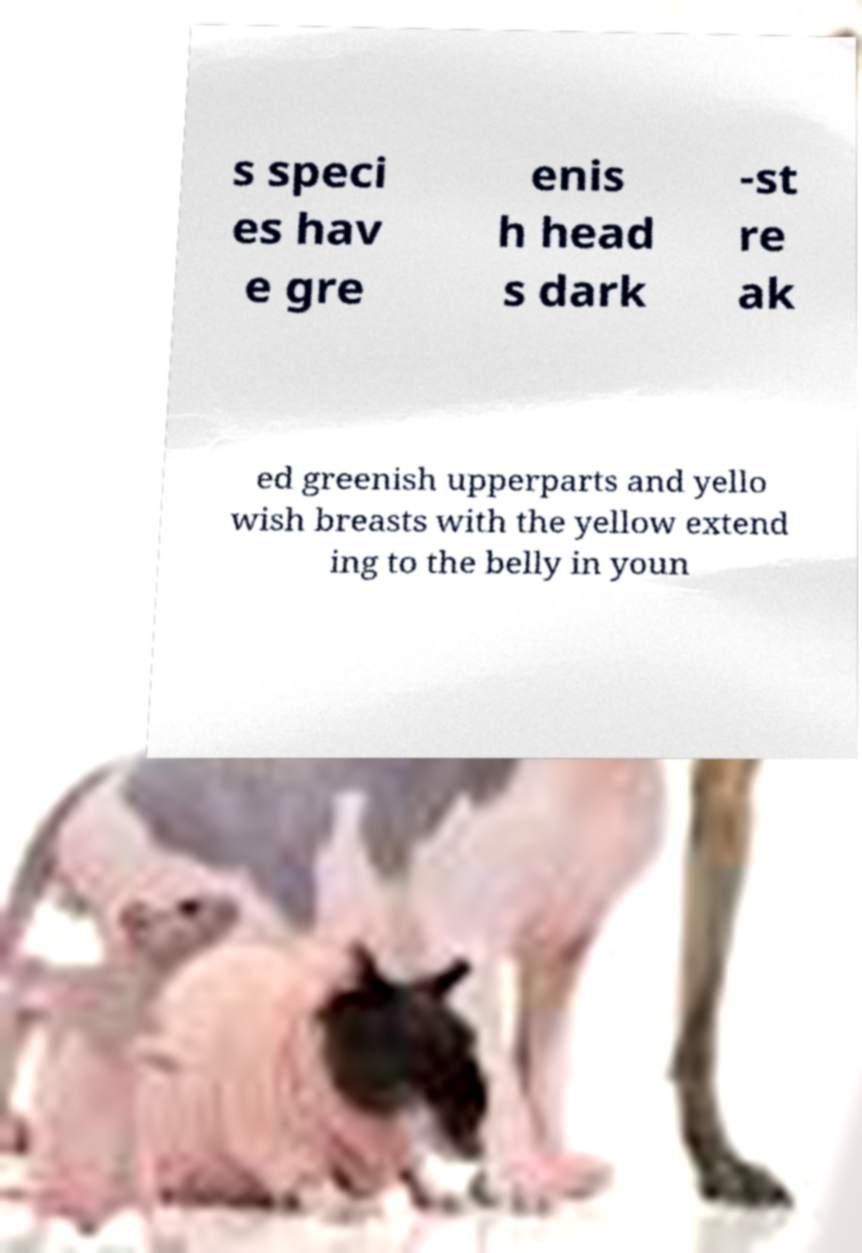What messages or text are displayed in this image? I need them in a readable, typed format. s speci es hav e gre enis h head s dark -st re ak ed greenish upperparts and yello wish breasts with the yellow extend ing to the belly in youn 